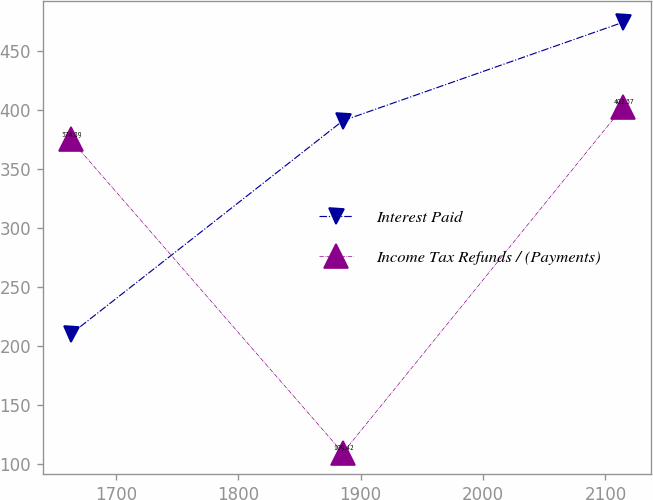Convert chart. <chart><loc_0><loc_0><loc_500><loc_500><line_chart><ecel><fcel>Interest Paid<fcel>Income Tax Refunds / (Payments)<nl><fcel>1663.04<fcel>209.8<fcel>374.89<nl><fcel>1885.54<fcel>390.72<fcel>109.42<nl><fcel>2114.47<fcel>474.1<fcel>402.37<nl></chart> 